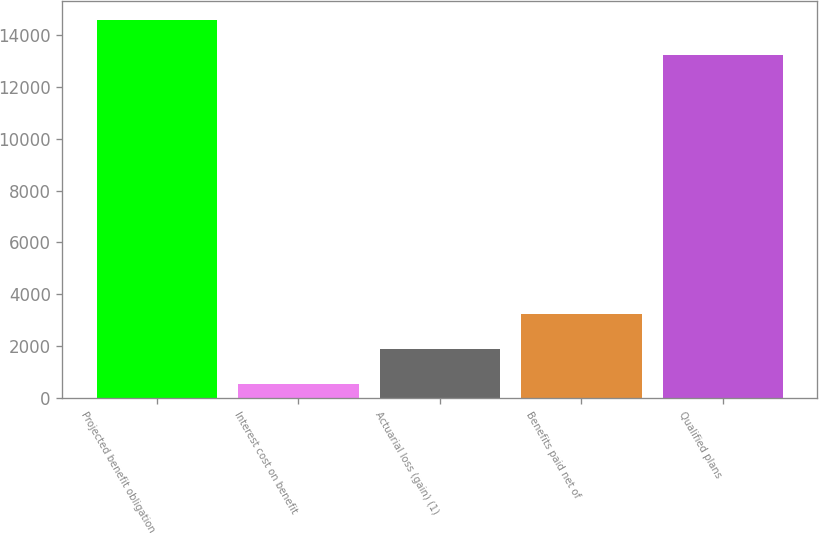Convert chart. <chart><loc_0><loc_0><loc_500><loc_500><bar_chart><fcel>Projected benefit obligation<fcel>Interest cost on benefit<fcel>Actuarial loss (gain) (1)<fcel>Benefits paid net of<fcel>Qualified plans<nl><fcel>14581.7<fcel>553<fcel>1903.7<fcel>3254.4<fcel>13231<nl></chart> 